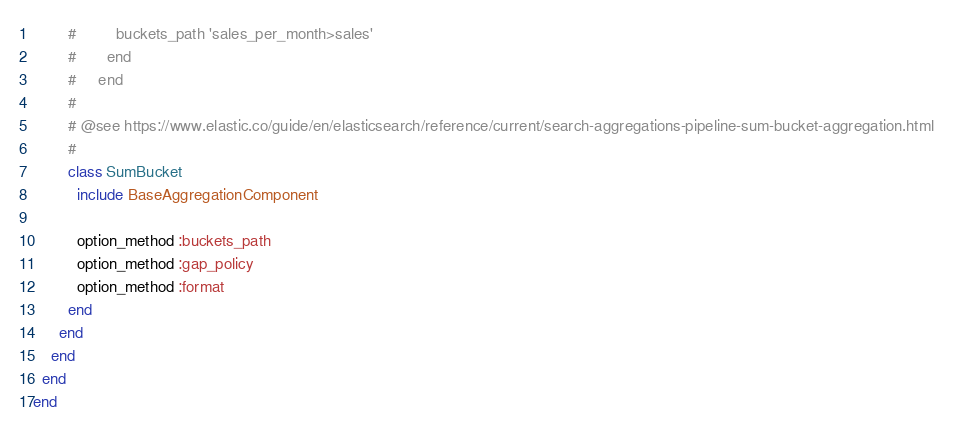<code> <loc_0><loc_0><loc_500><loc_500><_Ruby_>        #         buckets_path 'sales_per_month>sales'
        #       end
        #     end
        #
        # @see https://www.elastic.co/guide/en/elasticsearch/reference/current/search-aggregations-pipeline-sum-bucket-aggregation.html
        #
        class SumBucket
          include BaseAggregationComponent

          option_method :buckets_path
          option_method :gap_policy
          option_method :format
        end
      end
    end
  end
end
</code> 